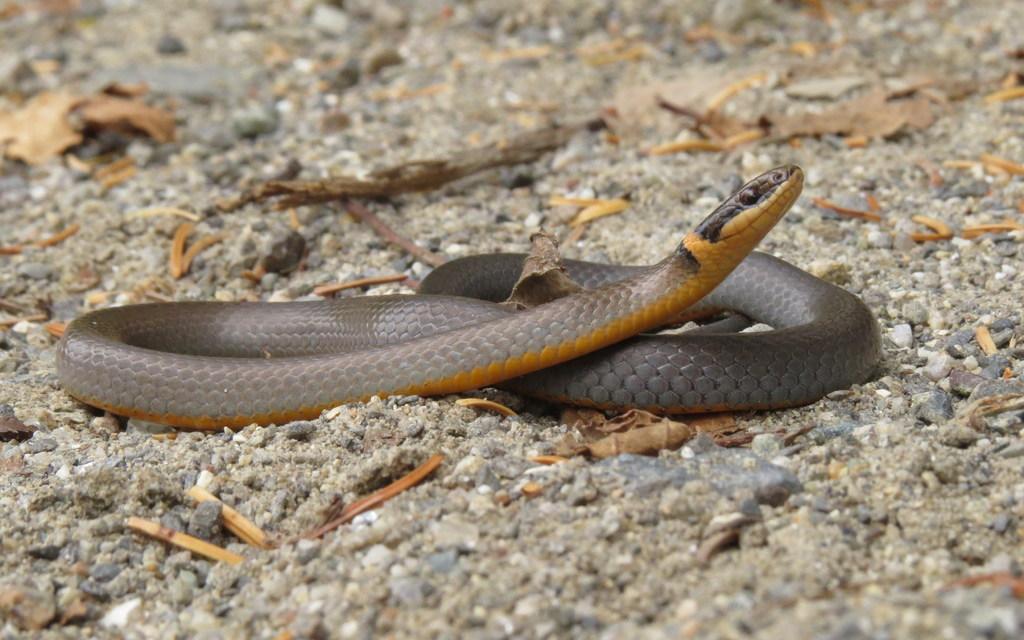In one or two sentences, can you explain what this image depicts? In this image we can see a snake and some wooden object on the land. 